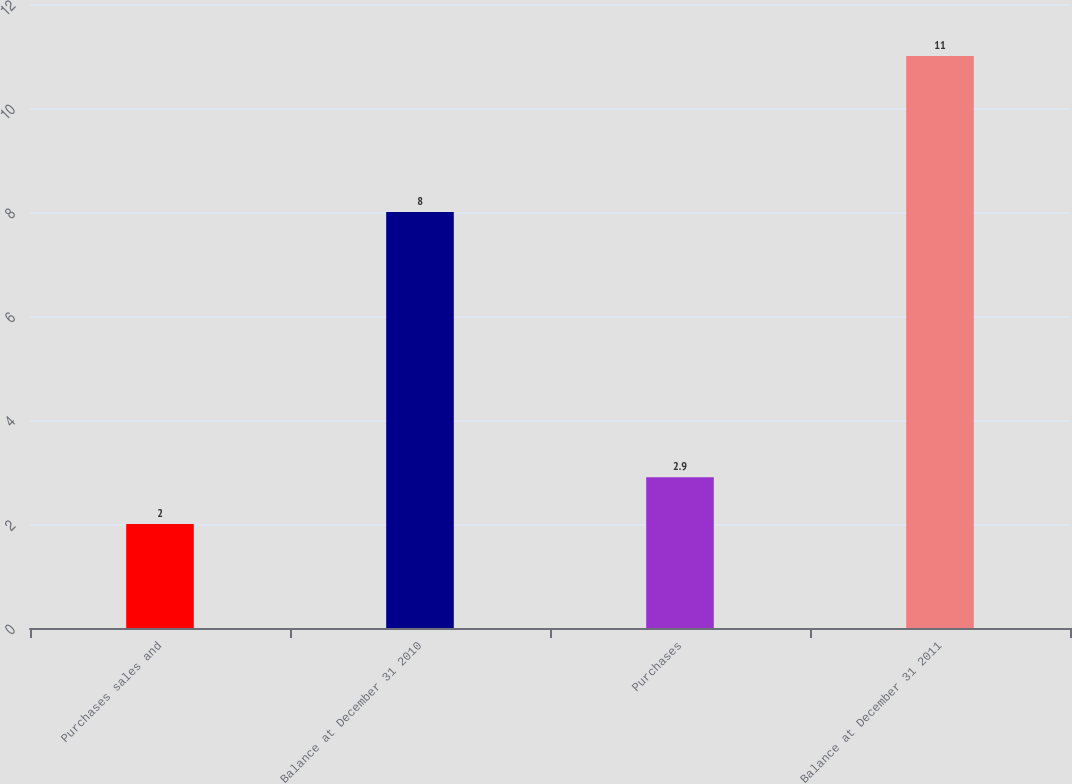<chart> <loc_0><loc_0><loc_500><loc_500><bar_chart><fcel>Purchases sales and<fcel>Balance at December 31 2010<fcel>Purchases<fcel>Balance at December 31 2011<nl><fcel>2<fcel>8<fcel>2.9<fcel>11<nl></chart> 